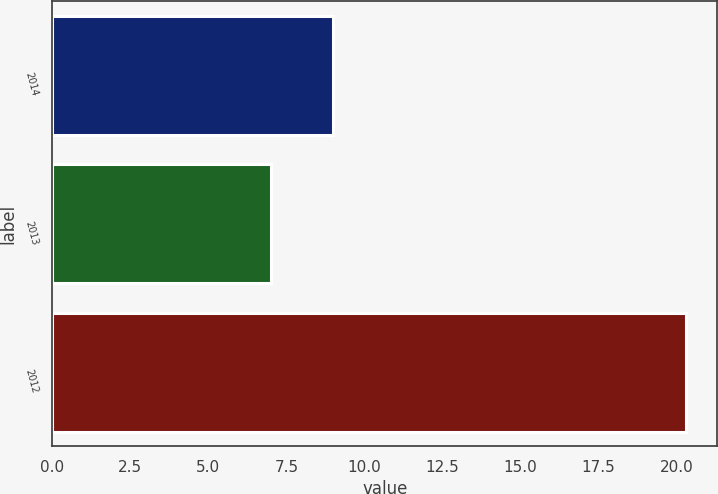Convert chart to OTSL. <chart><loc_0><loc_0><loc_500><loc_500><bar_chart><fcel>2014<fcel>2013<fcel>2012<nl><fcel>9<fcel>7<fcel>20.3<nl></chart> 